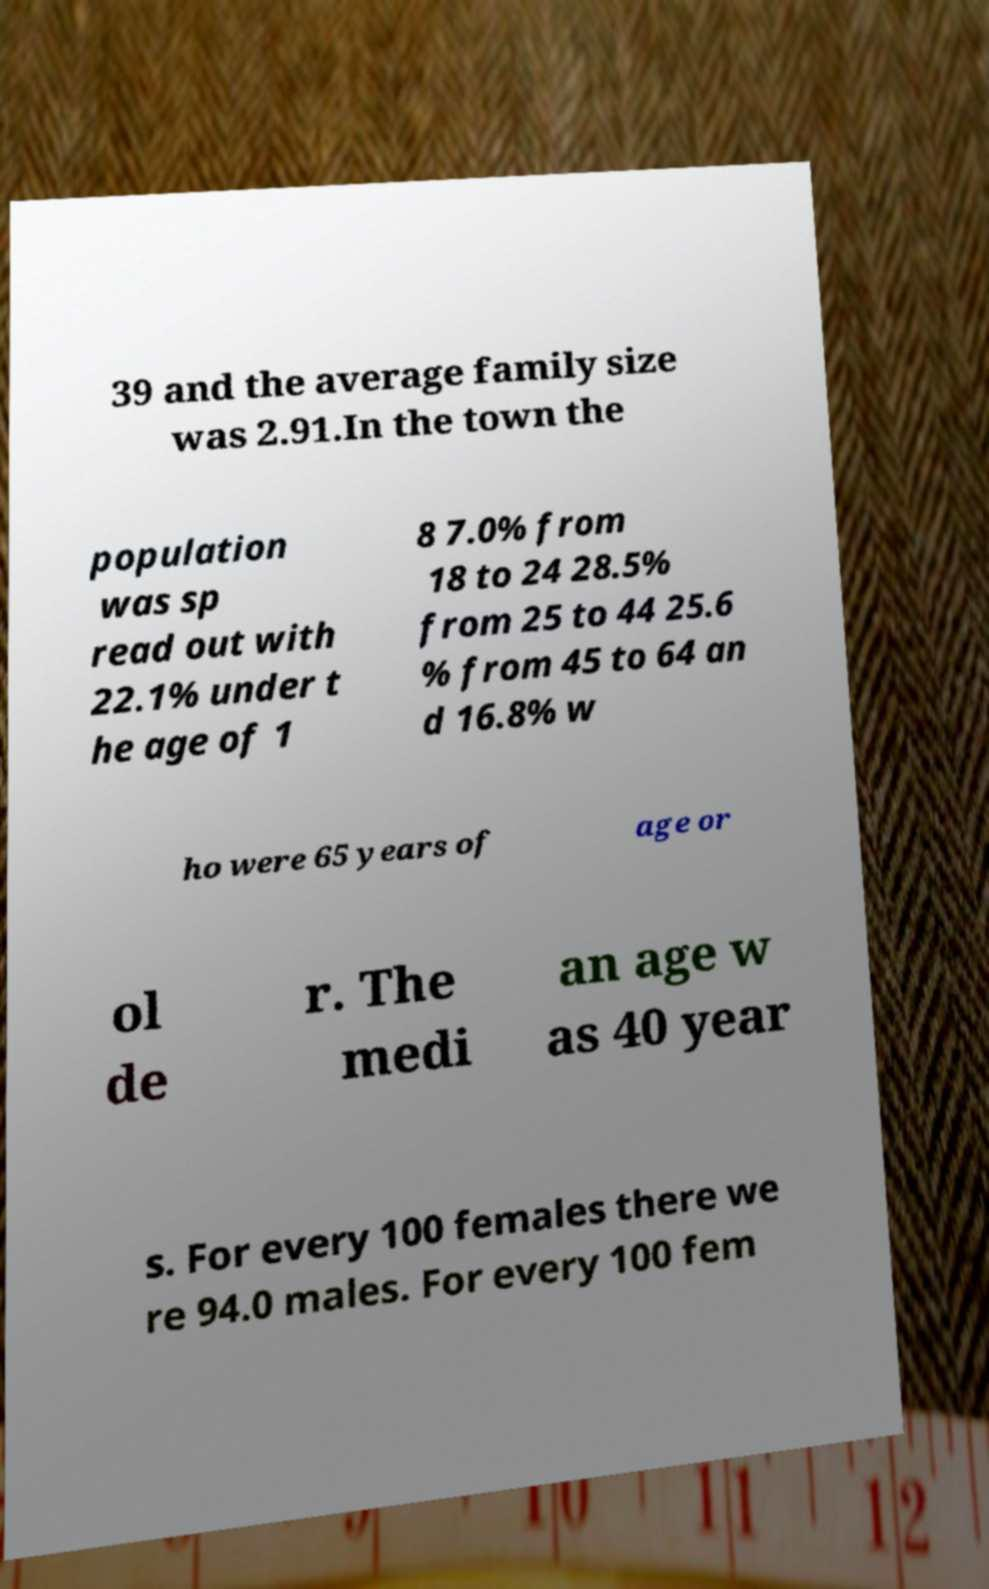For documentation purposes, I need the text within this image transcribed. Could you provide that? 39 and the average family size was 2.91.In the town the population was sp read out with 22.1% under t he age of 1 8 7.0% from 18 to 24 28.5% from 25 to 44 25.6 % from 45 to 64 an d 16.8% w ho were 65 years of age or ol de r. The medi an age w as 40 year s. For every 100 females there we re 94.0 males. For every 100 fem 